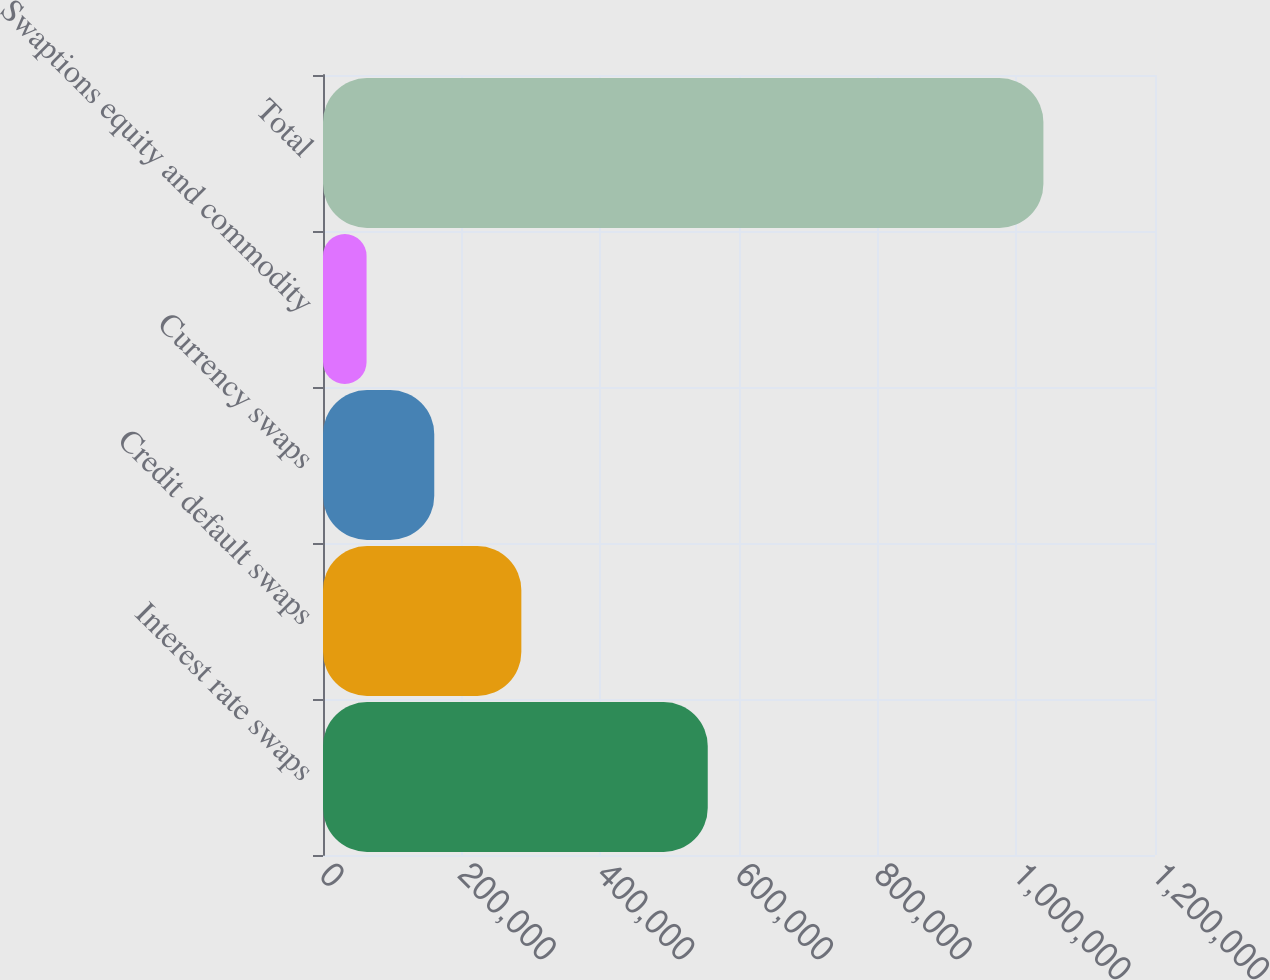Convert chart. <chart><loc_0><loc_0><loc_500><loc_500><bar_chart><fcel>Interest rate swaps<fcel>Credit default swaps<fcel>Currency swaps<fcel>Swaptions equity and commodity<fcel>Total<nl><fcel>554917<fcel>286069<fcel>160466<fcel>62849<fcel>1.03902e+06<nl></chart> 